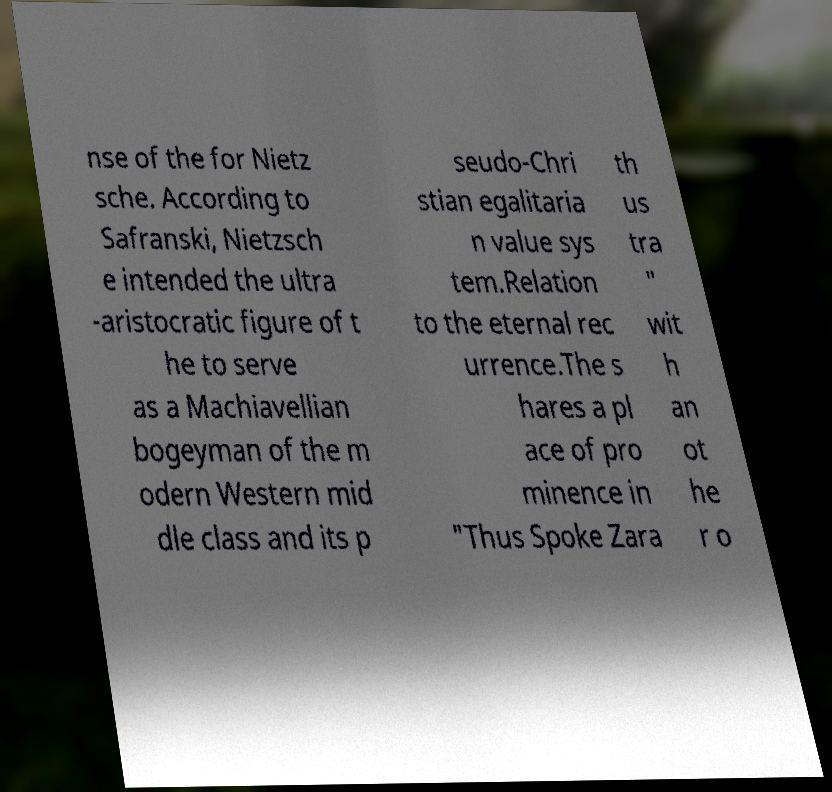Could you extract and type out the text from this image? nse of the for Nietz sche. According to Safranski, Nietzsch e intended the ultra -aristocratic figure of t he to serve as a Machiavellian bogeyman of the m odern Western mid dle class and its p seudo-Chri stian egalitaria n value sys tem.Relation to the eternal rec urrence.The s hares a pl ace of pro minence in "Thus Spoke Zara th us tra " wit h an ot he r o 